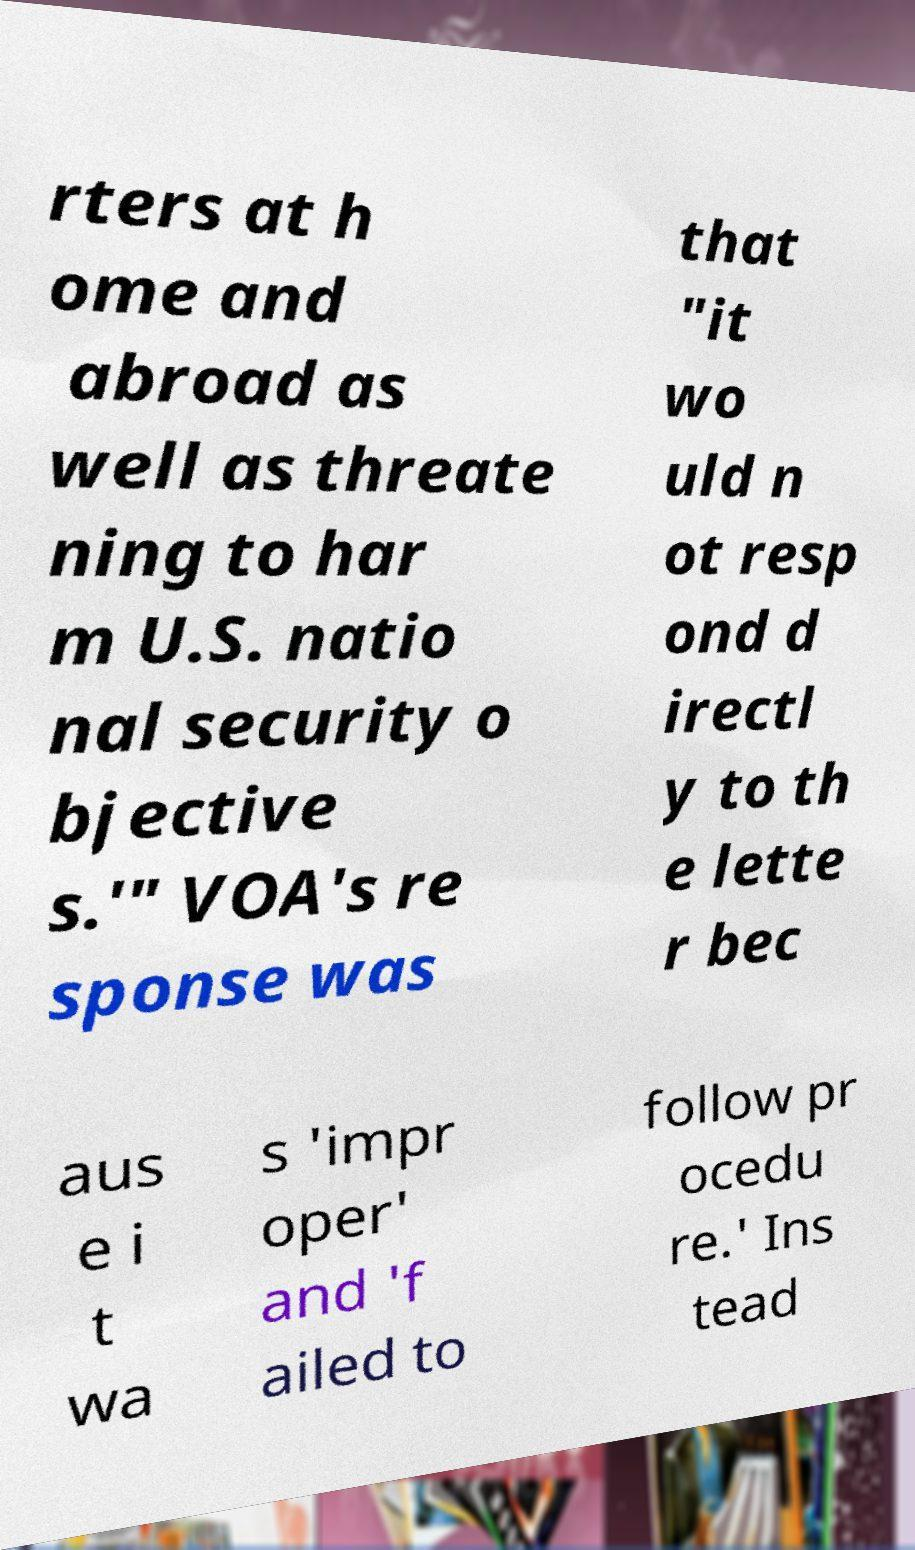What messages or text are displayed in this image? I need them in a readable, typed format. rters at h ome and abroad as well as threate ning to har m U.S. natio nal security o bjective s.'" VOA's re sponse was that "it wo uld n ot resp ond d irectl y to th e lette r bec aus e i t wa s 'impr oper' and 'f ailed to follow pr ocedu re.' Ins tead 